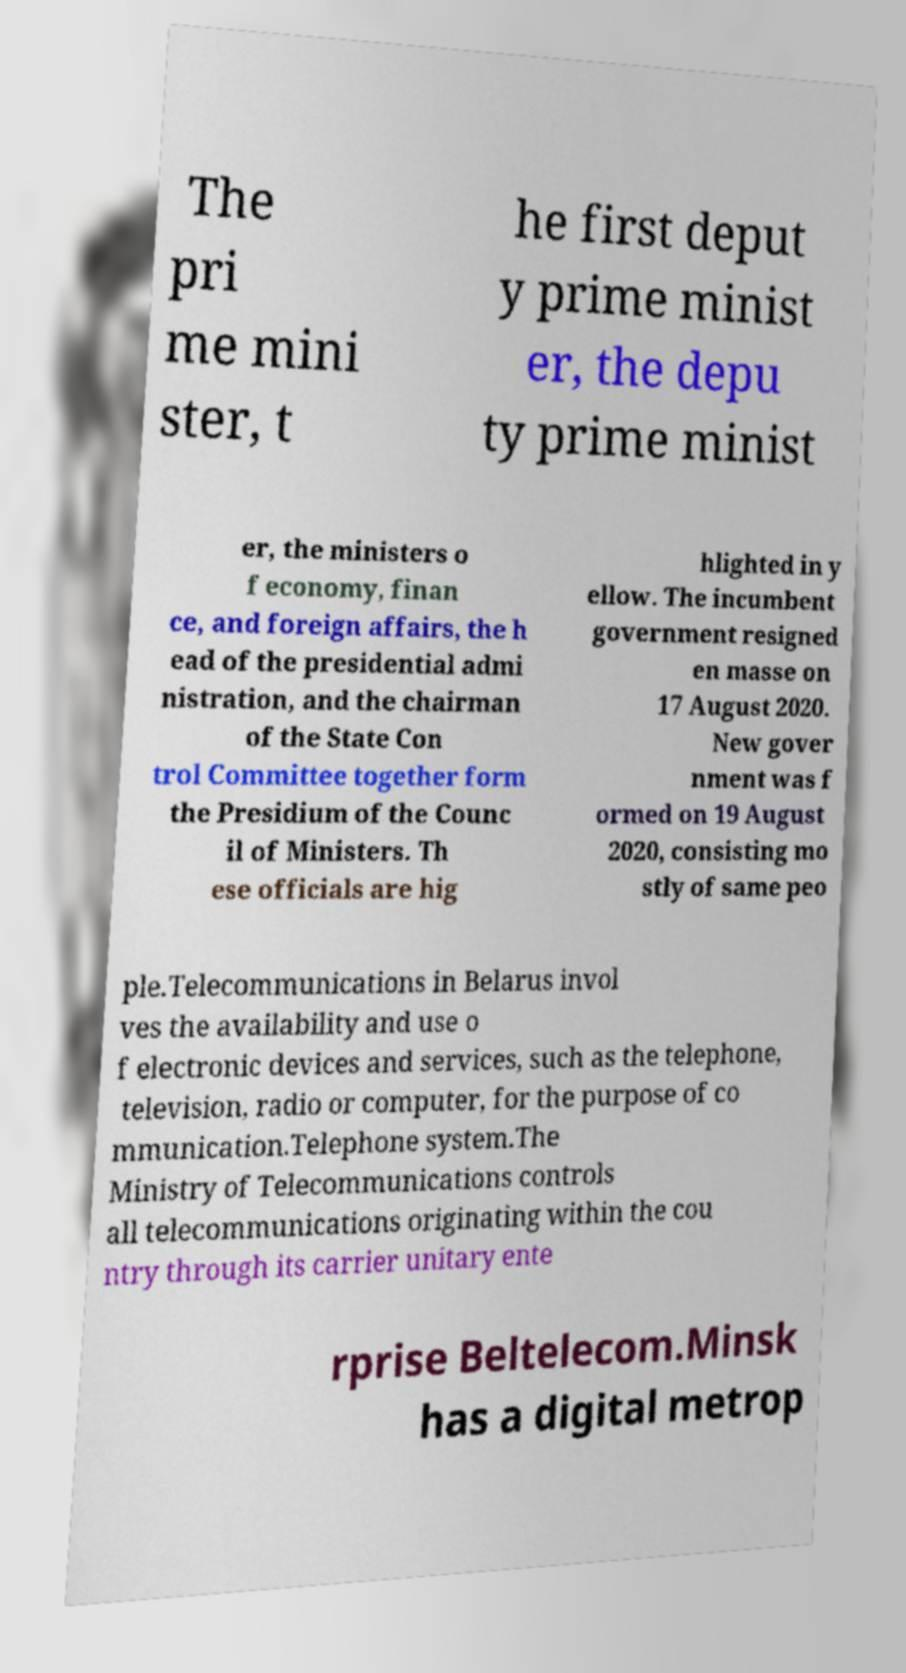Can you read and provide the text displayed in the image?This photo seems to have some interesting text. Can you extract and type it out for me? The pri me mini ster, t he first deput y prime minist er, the depu ty prime minist er, the ministers o f economy, finan ce, and foreign affairs, the h ead of the presidential admi nistration, and the chairman of the State Con trol Committee together form the Presidium of the Counc il of Ministers. Th ese officials are hig hlighted in y ellow. The incumbent government resigned en masse on 17 August 2020. New gover nment was f ormed on 19 August 2020, consisting mo stly of same peo ple.Telecommunications in Belarus invol ves the availability and use o f electronic devices and services, such as the telephone, television, radio or computer, for the purpose of co mmunication.Telephone system.The Ministry of Telecommunications controls all telecommunications originating within the cou ntry through its carrier unitary ente rprise Beltelecom.Minsk has a digital metrop 